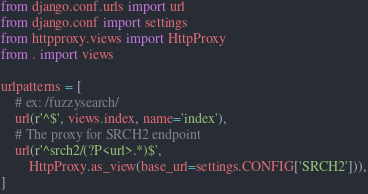<code> <loc_0><loc_0><loc_500><loc_500><_Python_>from django.conf.urls import url
from django.conf import settings
from httpproxy.views import HttpProxy
from . import views

urlpatterns = [
    # ex: /fuzzysearch/
    url(r'^$', views.index, name='index'),
    # The proxy for SRCH2 endpoint
    url(r'^srch2/(?P<url>.*)$',
        HttpProxy.as_view(base_url=settings.CONFIG['SRCH2'])),
]
</code> 